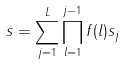<formula> <loc_0><loc_0><loc_500><loc_500>s = \sum _ { j = 1 } ^ { L } \prod _ { l = 1 } ^ { j - 1 } f ( l ) s _ { j }</formula> 